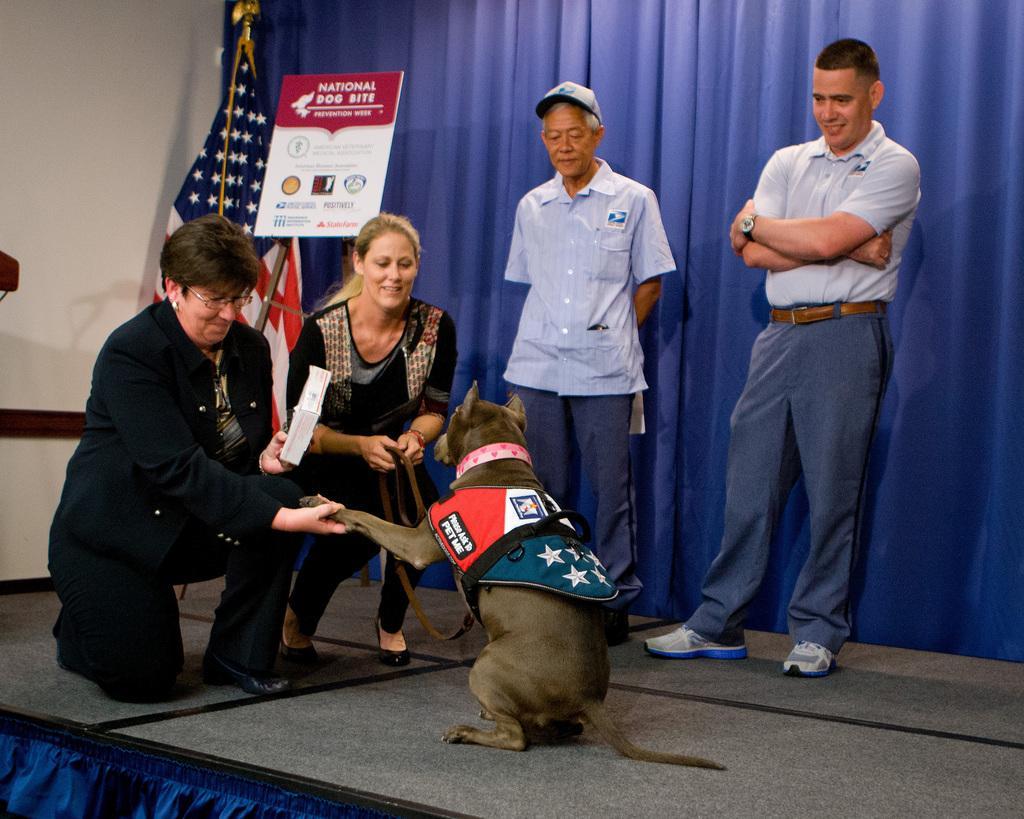Could you give a brief overview of what you see in this image? In this image i can see a dog, two women ,two man on a floor at the background i can see a curtain, a board and a flag, and a wall. 